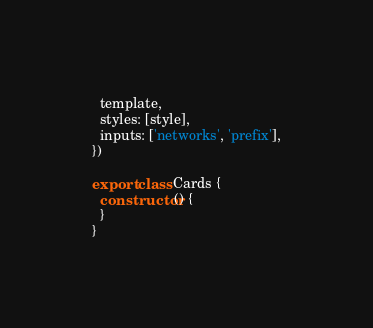Convert code to text. <code><loc_0><loc_0><loc_500><loc_500><_JavaScript_>  template,
  styles: [style],
  inputs: ['networks', 'prefix'],
})

export class Cards {
  constructor() {
  }
}
</code> 